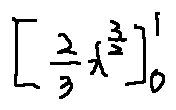Convert formula to latex. <formula><loc_0><loc_0><loc_500><loc_500>[ \frac { 2 } { 3 } x ^ { \frac { 3 } { 2 } } ] _ { 0 } ^ { 1 }</formula> 